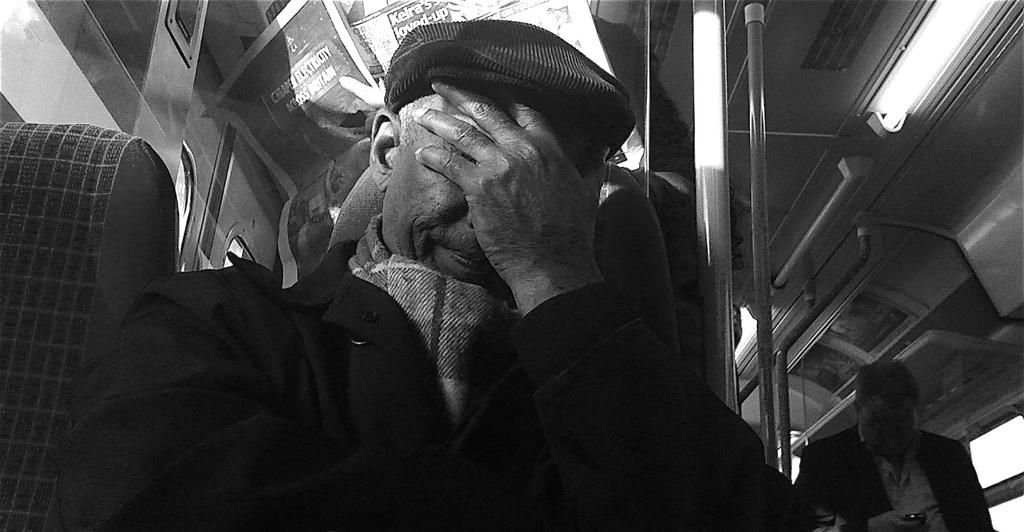What is the color scheme of the image? The image is black and white. Where was the image taken? The image was taken inside a train. Can you describe the main subject of the image? There is a person in the middle of the image. What can be seen at the top of the image? There are lights visible at the top of the image. What type of lettuce is being offered to the person in the image? There is no lettuce or offer present in the image; it is a black and white image taken inside a train with a person in the middle and lights visible at the top. 